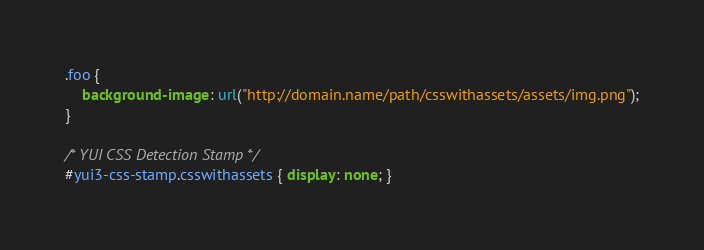<code> <loc_0><loc_0><loc_500><loc_500><_CSS_>.foo {
    background-image: url("http://domain.name/path/csswithassets/assets/img.png");
}

/* YUI CSS Detection Stamp */
#yui3-css-stamp.csswithassets { display: none; }
</code> 